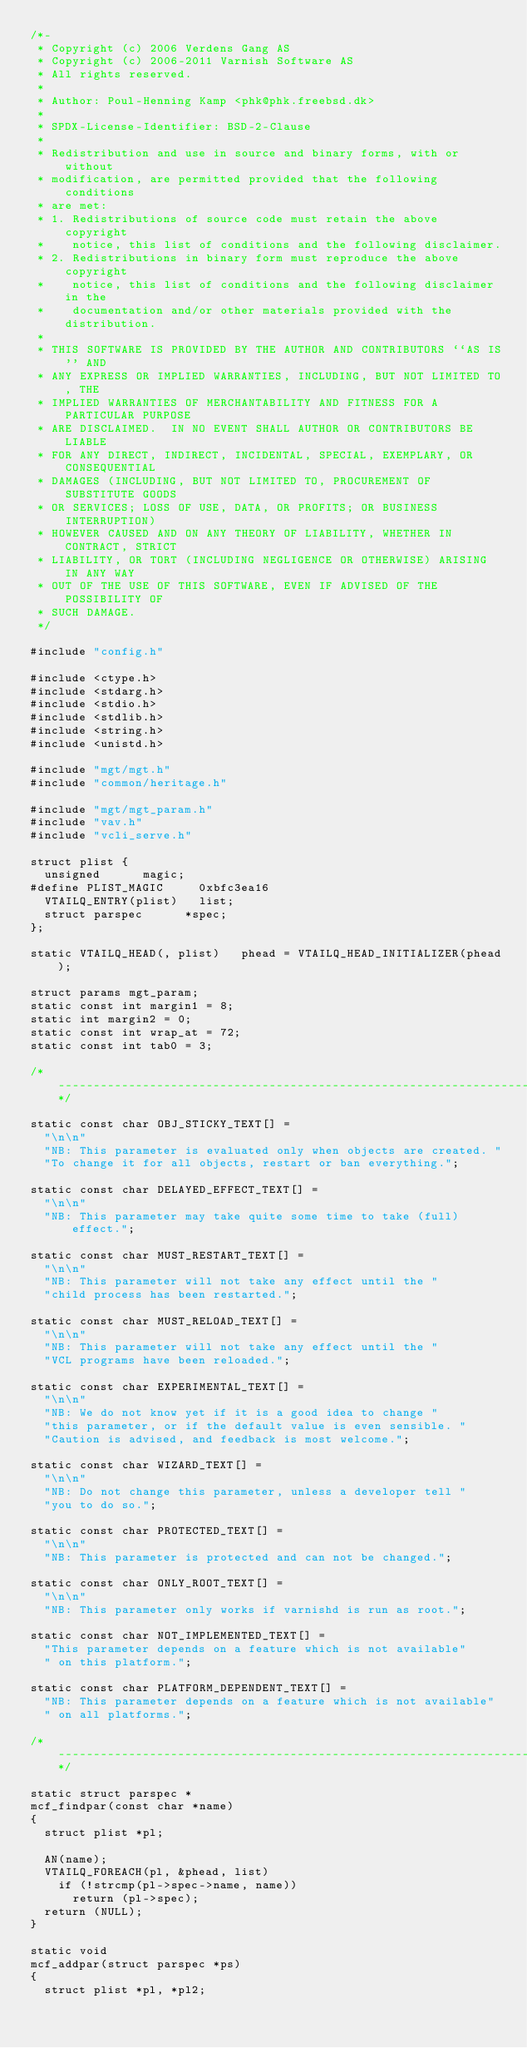Convert code to text. <code><loc_0><loc_0><loc_500><loc_500><_C_>/*-
 * Copyright (c) 2006 Verdens Gang AS
 * Copyright (c) 2006-2011 Varnish Software AS
 * All rights reserved.
 *
 * Author: Poul-Henning Kamp <phk@phk.freebsd.dk>
 *
 * SPDX-License-Identifier: BSD-2-Clause
 *
 * Redistribution and use in source and binary forms, with or without
 * modification, are permitted provided that the following conditions
 * are met:
 * 1. Redistributions of source code must retain the above copyright
 *    notice, this list of conditions and the following disclaimer.
 * 2. Redistributions in binary form must reproduce the above copyright
 *    notice, this list of conditions and the following disclaimer in the
 *    documentation and/or other materials provided with the distribution.
 *
 * THIS SOFTWARE IS PROVIDED BY THE AUTHOR AND CONTRIBUTORS ``AS IS'' AND
 * ANY EXPRESS OR IMPLIED WARRANTIES, INCLUDING, BUT NOT LIMITED TO, THE
 * IMPLIED WARRANTIES OF MERCHANTABILITY AND FITNESS FOR A PARTICULAR PURPOSE
 * ARE DISCLAIMED.  IN NO EVENT SHALL AUTHOR OR CONTRIBUTORS BE LIABLE
 * FOR ANY DIRECT, INDIRECT, INCIDENTAL, SPECIAL, EXEMPLARY, OR CONSEQUENTIAL
 * DAMAGES (INCLUDING, BUT NOT LIMITED TO, PROCUREMENT OF SUBSTITUTE GOODS
 * OR SERVICES; LOSS OF USE, DATA, OR PROFITS; OR BUSINESS INTERRUPTION)
 * HOWEVER CAUSED AND ON ANY THEORY OF LIABILITY, WHETHER IN CONTRACT, STRICT
 * LIABILITY, OR TORT (INCLUDING NEGLIGENCE OR OTHERWISE) ARISING IN ANY WAY
 * OUT OF THE USE OF THIS SOFTWARE, EVEN IF ADVISED OF THE POSSIBILITY OF
 * SUCH DAMAGE.
 */

#include "config.h"

#include <ctype.h>
#include <stdarg.h>
#include <stdio.h>
#include <stdlib.h>
#include <string.h>
#include <unistd.h>

#include "mgt/mgt.h"
#include "common/heritage.h"

#include "mgt/mgt_param.h"
#include "vav.h"
#include "vcli_serve.h"

struct plist {
	unsigned			magic;
#define PLIST_MAGIC			0xbfc3ea16
	VTAILQ_ENTRY(plist)		list;
	struct parspec			*spec;
};

static VTAILQ_HEAD(, plist)		phead = VTAILQ_HEAD_INITIALIZER(phead);

struct params mgt_param;
static const int margin1 = 8;
static int margin2 = 0;
static const int wrap_at = 72;
static const int tab0 = 3;

/*--------------------------------------------------------------------*/

static const char OBJ_STICKY_TEXT[] =
	"\n\n"
	"NB: This parameter is evaluated only when objects are created. "
	"To change it for all objects, restart or ban everything.";

static const char DELAYED_EFFECT_TEXT[] =
	"\n\n"
	"NB: This parameter may take quite some time to take (full) effect.";

static const char MUST_RESTART_TEXT[] =
	"\n\n"
	"NB: This parameter will not take any effect until the "
	"child process has been restarted.";

static const char MUST_RELOAD_TEXT[] =
	"\n\n"
	"NB: This parameter will not take any effect until the "
	"VCL programs have been reloaded.";

static const char EXPERIMENTAL_TEXT[] =
	"\n\n"
	"NB: We do not know yet if it is a good idea to change "
	"this parameter, or if the default value is even sensible. "
	"Caution is advised, and feedback is most welcome.";

static const char WIZARD_TEXT[] =
	"\n\n"
	"NB: Do not change this parameter, unless a developer tell "
	"you to do so.";

static const char PROTECTED_TEXT[] =
	"\n\n"
	"NB: This parameter is protected and can not be changed.";

static const char ONLY_ROOT_TEXT[] =
	"\n\n"
	"NB: This parameter only works if varnishd is run as root.";

static const char NOT_IMPLEMENTED_TEXT[] =
	"This parameter depends on a feature which is not available"
	" on this platform.";

static const char PLATFORM_DEPENDENT_TEXT[] =
	"NB: This parameter depends on a feature which is not available"
	" on all platforms.";

/*--------------------------------------------------------------------*/

static struct parspec *
mcf_findpar(const char *name)
{
	struct plist *pl;

	AN(name);
	VTAILQ_FOREACH(pl, &phead, list)
		if (!strcmp(pl->spec->name, name))
			return (pl->spec);
	return (NULL);
}

static void
mcf_addpar(struct parspec *ps)
{
	struct plist *pl, *pl2;</code> 